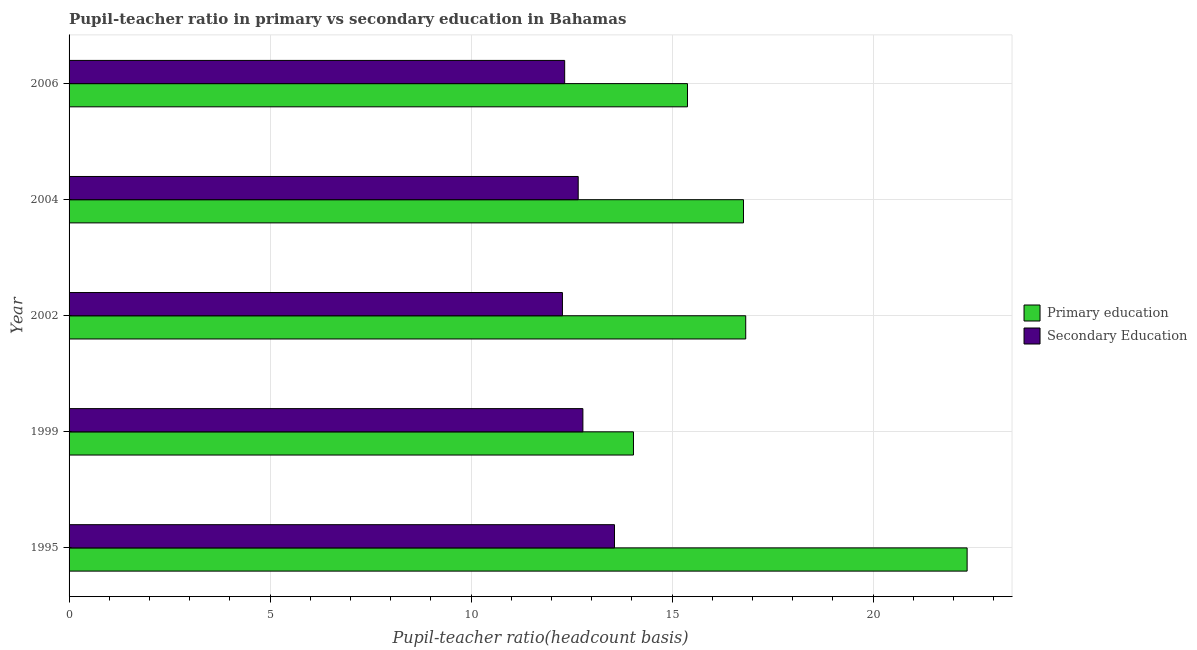How many different coloured bars are there?
Offer a terse response. 2. Are the number of bars per tick equal to the number of legend labels?
Offer a terse response. Yes. In how many cases, is the number of bars for a given year not equal to the number of legend labels?
Make the answer very short. 0. What is the pupil-teacher ratio in primary education in 2006?
Keep it short and to the point. 15.38. Across all years, what is the maximum pupil teacher ratio on secondary education?
Give a very brief answer. 13.57. Across all years, what is the minimum pupil teacher ratio on secondary education?
Make the answer very short. 12.27. In which year was the pupil-teacher ratio in primary education maximum?
Your answer should be very brief. 1995. What is the total pupil-teacher ratio in primary education in the graph?
Ensure brevity in your answer.  85.37. What is the difference between the pupil-teacher ratio in primary education in 1995 and that in 1999?
Offer a terse response. 8.3. What is the difference between the pupil-teacher ratio in primary education in 2004 and the pupil teacher ratio on secondary education in 2002?
Your response must be concise. 4.5. What is the average pupil teacher ratio on secondary education per year?
Offer a terse response. 12.72. In the year 2004, what is the difference between the pupil teacher ratio on secondary education and pupil-teacher ratio in primary education?
Give a very brief answer. -4.11. What is the ratio of the pupil teacher ratio on secondary education in 1995 to that in 2002?
Your answer should be compact. 1.11. Is the difference between the pupil teacher ratio on secondary education in 1999 and 2004 greater than the difference between the pupil-teacher ratio in primary education in 1999 and 2004?
Provide a short and direct response. Yes. What is the difference between the highest and the second highest pupil-teacher ratio in primary education?
Your response must be concise. 5.51. In how many years, is the pupil-teacher ratio in primary education greater than the average pupil-teacher ratio in primary education taken over all years?
Provide a succinct answer. 1. Is the sum of the pupil-teacher ratio in primary education in 1995 and 1999 greater than the maximum pupil teacher ratio on secondary education across all years?
Your answer should be compact. Yes. What does the 1st bar from the top in 1999 represents?
Keep it short and to the point. Secondary Education. What does the 2nd bar from the bottom in 2004 represents?
Make the answer very short. Secondary Education. How many bars are there?
Your response must be concise. 10. Are all the bars in the graph horizontal?
Provide a short and direct response. Yes. How many years are there in the graph?
Provide a short and direct response. 5. What is the difference between two consecutive major ticks on the X-axis?
Offer a very short reply. 5. Are the values on the major ticks of X-axis written in scientific E-notation?
Make the answer very short. No. Does the graph contain grids?
Your response must be concise. Yes. Where does the legend appear in the graph?
Your answer should be compact. Center right. How many legend labels are there?
Provide a short and direct response. 2. What is the title of the graph?
Your answer should be compact. Pupil-teacher ratio in primary vs secondary education in Bahamas. What is the label or title of the X-axis?
Provide a succinct answer. Pupil-teacher ratio(headcount basis). What is the Pupil-teacher ratio(headcount basis) of Primary education in 1995?
Offer a terse response. 22.34. What is the Pupil-teacher ratio(headcount basis) of Secondary Education in 1995?
Make the answer very short. 13.57. What is the Pupil-teacher ratio(headcount basis) in Primary education in 1999?
Make the answer very short. 14.04. What is the Pupil-teacher ratio(headcount basis) of Secondary Education in 1999?
Provide a short and direct response. 12.78. What is the Pupil-teacher ratio(headcount basis) in Primary education in 2002?
Your response must be concise. 16.83. What is the Pupil-teacher ratio(headcount basis) in Secondary Education in 2002?
Make the answer very short. 12.27. What is the Pupil-teacher ratio(headcount basis) of Primary education in 2004?
Provide a short and direct response. 16.78. What is the Pupil-teacher ratio(headcount basis) of Secondary Education in 2004?
Give a very brief answer. 12.67. What is the Pupil-teacher ratio(headcount basis) in Primary education in 2006?
Ensure brevity in your answer.  15.38. What is the Pupil-teacher ratio(headcount basis) of Secondary Education in 2006?
Provide a short and direct response. 12.33. Across all years, what is the maximum Pupil-teacher ratio(headcount basis) in Primary education?
Give a very brief answer. 22.34. Across all years, what is the maximum Pupil-teacher ratio(headcount basis) in Secondary Education?
Your response must be concise. 13.57. Across all years, what is the minimum Pupil-teacher ratio(headcount basis) in Primary education?
Ensure brevity in your answer.  14.04. Across all years, what is the minimum Pupil-teacher ratio(headcount basis) of Secondary Education?
Offer a very short reply. 12.27. What is the total Pupil-teacher ratio(headcount basis) of Primary education in the graph?
Provide a short and direct response. 85.37. What is the total Pupil-teacher ratio(headcount basis) of Secondary Education in the graph?
Provide a short and direct response. 63.62. What is the difference between the Pupil-teacher ratio(headcount basis) in Primary education in 1995 and that in 1999?
Your response must be concise. 8.3. What is the difference between the Pupil-teacher ratio(headcount basis) in Secondary Education in 1995 and that in 1999?
Keep it short and to the point. 0.79. What is the difference between the Pupil-teacher ratio(headcount basis) in Primary education in 1995 and that in 2002?
Give a very brief answer. 5.51. What is the difference between the Pupil-teacher ratio(headcount basis) in Secondary Education in 1995 and that in 2002?
Your answer should be very brief. 1.3. What is the difference between the Pupil-teacher ratio(headcount basis) in Primary education in 1995 and that in 2004?
Give a very brief answer. 5.56. What is the difference between the Pupil-teacher ratio(headcount basis) of Secondary Education in 1995 and that in 2004?
Offer a terse response. 0.9. What is the difference between the Pupil-teacher ratio(headcount basis) of Primary education in 1995 and that in 2006?
Your response must be concise. 6.96. What is the difference between the Pupil-teacher ratio(headcount basis) in Secondary Education in 1995 and that in 2006?
Offer a terse response. 1.24. What is the difference between the Pupil-teacher ratio(headcount basis) in Primary education in 1999 and that in 2002?
Your answer should be very brief. -2.79. What is the difference between the Pupil-teacher ratio(headcount basis) in Secondary Education in 1999 and that in 2002?
Your answer should be very brief. 0.51. What is the difference between the Pupil-teacher ratio(headcount basis) of Primary education in 1999 and that in 2004?
Provide a short and direct response. -2.74. What is the difference between the Pupil-teacher ratio(headcount basis) in Secondary Education in 1999 and that in 2004?
Your answer should be very brief. 0.12. What is the difference between the Pupil-teacher ratio(headcount basis) of Primary education in 1999 and that in 2006?
Give a very brief answer. -1.34. What is the difference between the Pupil-teacher ratio(headcount basis) in Secondary Education in 1999 and that in 2006?
Your answer should be very brief. 0.45. What is the difference between the Pupil-teacher ratio(headcount basis) of Primary education in 2002 and that in 2004?
Keep it short and to the point. 0.06. What is the difference between the Pupil-teacher ratio(headcount basis) in Secondary Education in 2002 and that in 2004?
Your answer should be compact. -0.39. What is the difference between the Pupil-teacher ratio(headcount basis) in Primary education in 2002 and that in 2006?
Offer a terse response. 1.45. What is the difference between the Pupil-teacher ratio(headcount basis) in Secondary Education in 2002 and that in 2006?
Offer a very short reply. -0.06. What is the difference between the Pupil-teacher ratio(headcount basis) in Primary education in 2004 and that in 2006?
Provide a short and direct response. 1.39. What is the difference between the Pupil-teacher ratio(headcount basis) of Secondary Education in 2004 and that in 2006?
Provide a succinct answer. 0.34. What is the difference between the Pupil-teacher ratio(headcount basis) of Primary education in 1995 and the Pupil-teacher ratio(headcount basis) of Secondary Education in 1999?
Give a very brief answer. 9.56. What is the difference between the Pupil-teacher ratio(headcount basis) in Primary education in 1995 and the Pupil-teacher ratio(headcount basis) in Secondary Education in 2002?
Give a very brief answer. 10.07. What is the difference between the Pupil-teacher ratio(headcount basis) in Primary education in 1995 and the Pupil-teacher ratio(headcount basis) in Secondary Education in 2004?
Offer a very short reply. 9.67. What is the difference between the Pupil-teacher ratio(headcount basis) in Primary education in 1995 and the Pupil-teacher ratio(headcount basis) in Secondary Education in 2006?
Offer a very short reply. 10.01. What is the difference between the Pupil-teacher ratio(headcount basis) in Primary education in 1999 and the Pupil-teacher ratio(headcount basis) in Secondary Education in 2002?
Offer a terse response. 1.77. What is the difference between the Pupil-teacher ratio(headcount basis) in Primary education in 1999 and the Pupil-teacher ratio(headcount basis) in Secondary Education in 2004?
Provide a succinct answer. 1.37. What is the difference between the Pupil-teacher ratio(headcount basis) in Primary education in 1999 and the Pupil-teacher ratio(headcount basis) in Secondary Education in 2006?
Your answer should be compact. 1.71. What is the difference between the Pupil-teacher ratio(headcount basis) of Primary education in 2002 and the Pupil-teacher ratio(headcount basis) of Secondary Education in 2004?
Make the answer very short. 4.17. What is the difference between the Pupil-teacher ratio(headcount basis) in Primary education in 2002 and the Pupil-teacher ratio(headcount basis) in Secondary Education in 2006?
Provide a succinct answer. 4.5. What is the difference between the Pupil-teacher ratio(headcount basis) in Primary education in 2004 and the Pupil-teacher ratio(headcount basis) in Secondary Education in 2006?
Provide a short and direct response. 4.45. What is the average Pupil-teacher ratio(headcount basis) in Primary education per year?
Keep it short and to the point. 17.07. What is the average Pupil-teacher ratio(headcount basis) of Secondary Education per year?
Provide a short and direct response. 12.72. In the year 1995, what is the difference between the Pupil-teacher ratio(headcount basis) of Primary education and Pupil-teacher ratio(headcount basis) of Secondary Education?
Offer a very short reply. 8.77. In the year 1999, what is the difference between the Pupil-teacher ratio(headcount basis) in Primary education and Pupil-teacher ratio(headcount basis) in Secondary Education?
Provide a succinct answer. 1.26. In the year 2002, what is the difference between the Pupil-teacher ratio(headcount basis) of Primary education and Pupil-teacher ratio(headcount basis) of Secondary Education?
Offer a terse response. 4.56. In the year 2004, what is the difference between the Pupil-teacher ratio(headcount basis) in Primary education and Pupil-teacher ratio(headcount basis) in Secondary Education?
Keep it short and to the point. 4.11. In the year 2006, what is the difference between the Pupil-teacher ratio(headcount basis) in Primary education and Pupil-teacher ratio(headcount basis) in Secondary Education?
Your response must be concise. 3.05. What is the ratio of the Pupil-teacher ratio(headcount basis) of Primary education in 1995 to that in 1999?
Your answer should be compact. 1.59. What is the ratio of the Pupil-teacher ratio(headcount basis) of Secondary Education in 1995 to that in 1999?
Offer a terse response. 1.06. What is the ratio of the Pupil-teacher ratio(headcount basis) of Primary education in 1995 to that in 2002?
Offer a very short reply. 1.33. What is the ratio of the Pupil-teacher ratio(headcount basis) in Secondary Education in 1995 to that in 2002?
Provide a short and direct response. 1.11. What is the ratio of the Pupil-teacher ratio(headcount basis) in Primary education in 1995 to that in 2004?
Give a very brief answer. 1.33. What is the ratio of the Pupil-teacher ratio(headcount basis) of Secondary Education in 1995 to that in 2004?
Give a very brief answer. 1.07. What is the ratio of the Pupil-teacher ratio(headcount basis) in Primary education in 1995 to that in 2006?
Provide a short and direct response. 1.45. What is the ratio of the Pupil-teacher ratio(headcount basis) of Secondary Education in 1995 to that in 2006?
Keep it short and to the point. 1.1. What is the ratio of the Pupil-teacher ratio(headcount basis) of Primary education in 1999 to that in 2002?
Offer a very short reply. 0.83. What is the ratio of the Pupil-teacher ratio(headcount basis) of Secondary Education in 1999 to that in 2002?
Offer a very short reply. 1.04. What is the ratio of the Pupil-teacher ratio(headcount basis) of Primary education in 1999 to that in 2004?
Provide a succinct answer. 0.84. What is the ratio of the Pupil-teacher ratio(headcount basis) in Secondary Education in 1999 to that in 2004?
Your response must be concise. 1.01. What is the ratio of the Pupil-teacher ratio(headcount basis) of Primary education in 1999 to that in 2006?
Your response must be concise. 0.91. What is the ratio of the Pupil-teacher ratio(headcount basis) of Secondary Education in 1999 to that in 2006?
Give a very brief answer. 1.04. What is the ratio of the Pupil-teacher ratio(headcount basis) of Primary education in 2002 to that in 2004?
Provide a succinct answer. 1. What is the ratio of the Pupil-teacher ratio(headcount basis) of Secondary Education in 2002 to that in 2004?
Your answer should be very brief. 0.97. What is the ratio of the Pupil-teacher ratio(headcount basis) of Primary education in 2002 to that in 2006?
Your answer should be compact. 1.09. What is the ratio of the Pupil-teacher ratio(headcount basis) of Primary education in 2004 to that in 2006?
Your response must be concise. 1.09. What is the ratio of the Pupil-teacher ratio(headcount basis) of Secondary Education in 2004 to that in 2006?
Your response must be concise. 1.03. What is the difference between the highest and the second highest Pupil-teacher ratio(headcount basis) in Primary education?
Your answer should be compact. 5.51. What is the difference between the highest and the second highest Pupil-teacher ratio(headcount basis) of Secondary Education?
Your answer should be very brief. 0.79. What is the difference between the highest and the lowest Pupil-teacher ratio(headcount basis) of Primary education?
Offer a very short reply. 8.3. What is the difference between the highest and the lowest Pupil-teacher ratio(headcount basis) of Secondary Education?
Your response must be concise. 1.3. 